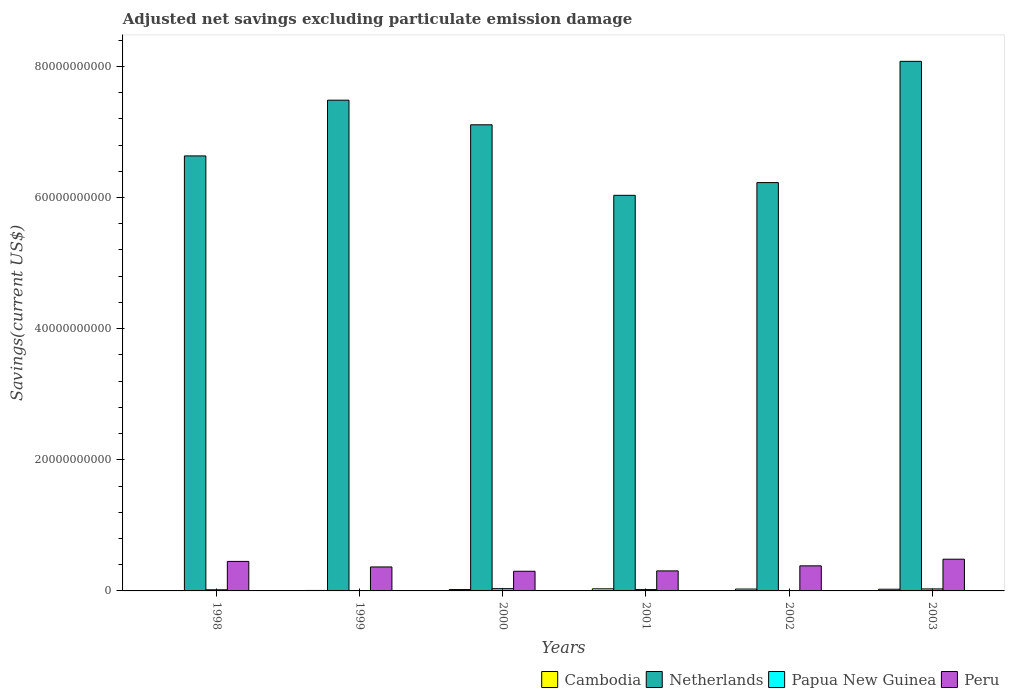How many groups of bars are there?
Offer a terse response. 6. Are the number of bars on each tick of the X-axis equal?
Keep it short and to the point. No. What is the label of the 3rd group of bars from the left?
Keep it short and to the point. 2000. In how many cases, is the number of bars for a given year not equal to the number of legend labels?
Your response must be concise. 3. What is the adjusted net savings in Cambodia in 1999?
Your answer should be compact. 7.21e+07. Across all years, what is the maximum adjusted net savings in Papua New Guinea?
Offer a very short reply. 3.44e+08. What is the total adjusted net savings in Cambodia in the graph?
Provide a succinct answer. 1.14e+09. What is the difference between the adjusted net savings in Netherlands in 2002 and that in 2003?
Offer a very short reply. -1.85e+1. What is the difference between the adjusted net savings in Peru in 2000 and the adjusted net savings in Netherlands in 2001?
Keep it short and to the point. -5.73e+1. What is the average adjusted net savings in Papua New Guinea per year?
Your answer should be very brief. 1.71e+08. In the year 1999, what is the difference between the adjusted net savings in Netherlands and adjusted net savings in Peru?
Make the answer very short. 7.12e+1. What is the ratio of the adjusted net savings in Peru in 2001 to that in 2003?
Your answer should be very brief. 0.63. What is the difference between the highest and the second highest adjusted net savings in Peru?
Offer a terse response. 3.38e+08. What is the difference between the highest and the lowest adjusted net savings in Netherlands?
Give a very brief answer. 2.04e+1. In how many years, is the adjusted net savings in Peru greater than the average adjusted net savings in Peru taken over all years?
Offer a very short reply. 3. Is the sum of the adjusted net savings in Papua New Guinea in 1998 and 2003 greater than the maximum adjusted net savings in Peru across all years?
Your response must be concise. No. How many bars are there?
Offer a very short reply. 21. What is the difference between two consecutive major ticks on the Y-axis?
Keep it short and to the point. 2.00e+1. Does the graph contain any zero values?
Your answer should be very brief. Yes. Does the graph contain grids?
Ensure brevity in your answer.  No. Where does the legend appear in the graph?
Provide a short and direct response. Bottom right. What is the title of the graph?
Ensure brevity in your answer.  Adjusted net savings excluding particulate emission damage. Does "Cabo Verde" appear as one of the legend labels in the graph?
Give a very brief answer. No. What is the label or title of the Y-axis?
Make the answer very short. Savings(current US$). What is the Savings(current US$) of Cambodia in 1998?
Provide a short and direct response. 0. What is the Savings(current US$) in Netherlands in 1998?
Provide a succinct answer. 6.63e+1. What is the Savings(current US$) of Papua New Guinea in 1998?
Provide a succinct answer. 1.72e+08. What is the Savings(current US$) in Peru in 1998?
Provide a short and direct response. 4.50e+09. What is the Savings(current US$) of Cambodia in 1999?
Provide a short and direct response. 7.21e+07. What is the Savings(current US$) of Netherlands in 1999?
Your response must be concise. 7.48e+1. What is the Savings(current US$) in Papua New Guinea in 1999?
Your answer should be very brief. 0. What is the Savings(current US$) of Peru in 1999?
Keep it short and to the point. 3.66e+09. What is the Savings(current US$) in Cambodia in 2000?
Your response must be concise. 2.06e+08. What is the Savings(current US$) of Netherlands in 2000?
Provide a succinct answer. 7.11e+1. What is the Savings(current US$) in Papua New Guinea in 2000?
Your answer should be very brief. 3.44e+08. What is the Savings(current US$) in Peru in 2000?
Your response must be concise. 3.00e+09. What is the Savings(current US$) of Cambodia in 2001?
Provide a short and direct response. 3.20e+08. What is the Savings(current US$) in Netherlands in 2001?
Offer a very short reply. 6.03e+1. What is the Savings(current US$) in Papua New Guinea in 2001?
Ensure brevity in your answer.  2.01e+08. What is the Savings(current US$) in Peru in 2001?
Offer a very short reply. 3.05e+09. What is the Savings(current US$) of Cambodia in 2002?
Provide a succinct answer. 2.86e+08. What is the Savings(current US$) in Netherlands in 2002?
Keep it short and to the point. 6.23e+1. What is the Savings(current US$) in Papua New Guinea in 2002?
Give a very brief answer. 0. What is the Savings(current US$) of Peru in 2002?
Keep it short and to the point. 3.82e+09. What is the Savings(current US$) of Cambodia in 2003?
Give a very brief answer. 2.59e+08. What is the Savings(current US$) in Netherlands in 2003?
Provide a short and direct response. 8.08e+1. What is the Savings(current US$) in Papua New Guinea in 2003?
Your answer should be compact. 3.07e+08. What is the Savings(current US$) of Peru in 2003?
Your answer should be very brief. 4.84e+09. Across all years, what is the maximum Savings(current US$) of Cambodia?
Your answer should be very brief. 3.20e+08. Across all years, what is the maximum Savings(current US$) in Netherlands?
Give a very brief answer. 8.08e+1. Across all years, what is the maximum Savings(current US$) of Papua New Guinea?
Your response must be concise. 3.44e+08. Across all years, what is the maximum Savings(current US$) of Peru?
Make the answer very short. 4.84e+09. Across all years, what is the minimum Savings(current US$) in Netherlands?
Your response must be concise. 6.03e+1. Across all years, what is the minimum Savings(current US$) in Papua New Guinea?
Your response must be concise. 0. Across all years, what is the minimum Savings(current US$) in Peru?
Offer a very short reply. 3.00e+09. What is the total Savings(current US$) of Cambodia in the graph?
Provide a succinct answer. 1.14e+09. What is the total Savings(current US$) of Netherlands in the graph?
Ensure brevity in your answer.  4.16e+11. What is the total Savings(current US$) in Papua New Guinea in the graph?
Keep it short and to the point. 1.02e+09. What is the total Savings(current US$) of Peru in the graph?
Your response must be concise. 2.29e+1. What is the difference between the Savings(current US$) of Netherlands in 1998 and that in 1999?
Ensure brevity in your answer.  -8.50e+09. What is the difference between the Savings(current US$) of Peru in 1998 and that in 1999?
Your answer should be compact. 8.45e+08. What is the difference between the Savings(current US$) of Netherlands in 1998 and that in 2000?
Provide a succinct answer. -4.75e+09. What is the difference between the Savings(current US$) in Papua New Guinea in 1998 and that in 2000?
Offer a very short reply. -1.72e+08. What is the difference between the Savings(current US$) in Peru in 1998 and that in 2000?
Your answer should be compact. 1.50e+09. What is the difference between the Savings(current US$) of Netherlands in 1998 and that in 2001?
Keep it short and to the point. 6.01e+09. What is the difference between the Savings(current US$) in Papua New Guinea in 1998 and that in 2001?
Give a very brief answer. -2.91e+07. What is the difference between the Savings(current US$) in Peru in 1998 and that in 2001?
Your answer should be compact. 1.45e+09. What is the difference between the Savings(current US$) in Netherlands in 1998 and that in 2002?
Ensure brevity in your answer.  4.07e+09. What is the difference between the Savings(current US$) in Peru in 1998 and that in 2002?
Keep it short and to the point. 6.79e+08. What is the difference between the Savings(current US$) in Netherlands in 1998 and that in 2003?
Your answer should be very brief. -1.44e+1. What is the difference between the Savings(current US$) of Papua New Guinea in 1998 and that in 2003?
Offer a very short reply. -1.35e+08. What is the difference between the Savings(current US$) in Peru in 1998 and that in 2003?
Offer a very short reply. -3.38e+08. What is the difference between the Savings(current US$) in Cambodia in 1999 and that in 2000?
Offer a terse response. -1.34e+08. What is the difference between the Savings(current US$) in Netherlands in 1999 and that in 2000?
Keep it short and to the point. 3.75e+09. What is the difference between the Savings(current US$) in Peru in 1999 and that in 2000?
Offer a terse response. 6.57e+08. What is the difference between the Savings(current US$) of Cambodia in 1999 and that in 2001?
Make the answer very short. -2.48e+08. What is the difference between the Savings(current US$) of Netherlands in 1999 and that in 2001?
Your answer should be very brief. 1.45e+1. What is the difference between the Savings(current US$) in Peru in 1999 and that in 2001?
Keep it short and to the point. 6.03e+08. What is the difference between the Savings(current US$) of Cambodia in 1999 and that in 2002?
Your response must be concise. -2.14e+08. What is the difference between the Savings(current US$) in Netherlands in 1999 and that in 2002?
Your answer should be very brief. 1.26e+1. What is the difference between the Savings(current US$) of Peru in 1999 and that in 2002?
Offer a very short reply. -1.66e+08. What is the difference between the Savings(current US$) in Cambodia in 1999 and that in 2003?
Keep it short and to the point. -1.87e+08. What is the difference between the Savings(current US$) of Netherlands in 1999 and that in 2003?
Offer a very short reply. -5.92e+09. What is the difference between the Savings(current US$) of Peru in 1999 and that in 2003?
Give a very brief answer. -1.18e+09. What is the difference between the Savings(current US$) of Cambodia in 2000 and that in 2001?
Your response must be concise. -1.14e+08. What is the difference between the Savings(current US$) of Netherlands in 2000 and that in 2001?
Your answer should be compact. 1.08e+1. What is the difference between the Savings(current US$) of Papua New Guinea in 2000 and that in 2001?
Offer a very short reply. 1.43e+08. What is the difference between the Savings(current US$) in Peru in 2000 and that in 2001?
Provide a succinct answer. -5.41e+07. What is the difference between the Savings(current US$) in Cambodia in 2000 and that in 2002?
Ensure brevity in your answer.  -7.97e+07. What is the difference between the Savings(current US$) of Netherlands in 2000 and that in 2002?
Offer a terse response. 8.82e+09. What is the difference between the Savings(current US$) of Peru in 2000 and that in 2002?
Your answer should be very brief. -8.23e+08. What is the difference between the Savings(current US$) in Cambodia in 2000 and that in 2003?
Provide a short and direct response. -5.29e+07. What is the difference between the Savings(current US$) of Netherlands in 2000 and that in 2003?
Provide a succinct answer. -9.68e+09. What is the difference between the Savings(current US$) in Papua New Guinea in 2000 and that in 2003?
Your answer should be compact. 3.68e+07. What is the difference between the Savings(current US$) in Peru in 2000 and that in 2003?
Make the answer very short. -1.84e+09. What is the difference between the Savings(current US$) of Cambodia in 2001 and that in 2002?
Ensure brevity in your answer.  3.47e+07. What is the difference between the Savings(current US$) of Netherlands in 2001 and that in 2002?
Keep it short and to the point. -1.94e+09. What is the difference between the Savings(current US$) of Peru in 2001 and that in 2002?
Offer a terse response. -7.69e+08. What is the difference between the Savings(current US$) in Cambodia in 2001 and that in 2003?
Your response must be concise. 6.15e+07. What is the difference between the Savings(current US$) in Netherlands in 2001 and that in 2003?
Make the answer very short. -2.04e+1. What is the difference between the Savings(current US$) of Papua New Guinea in 2001 and that in 2003?
Provide a short and direct response. -1.06e+08. What is the difference between the Savings(current US$) of Peru in 2001 and that in 2003?
Offer a terse response. -1.78e+09. What is the difference between the Savings(current US$) in Cambodia in 2002 and that in 2003?
Make the answer very short. 2.68e+07. What is the difference between the Savings(current US$) in Netherlands in 2002 and that in 2003?
Your answer should be compact. -1.85e+1. What is the difference between the Savings(current US$) of Peru in 2002 and that in 2003?
Ensure brevity in your answer.  -1.02e+09. What is the difference between the Savings(current US$) in Netherlands in 1998 and the Savings(current US$) in Peru in 1999?
Give a very brief answer. 6.27e+1. What is the difference between the Savings(current US$) in Papua New Guinea in 1998 and the Savings(current US$) in Peru in 1999?
Offer a very short reply. -3.48e+09. What is the difference between the Savings(current US$) of Netherlands in 1998 and the Savings(current US$) of Papua New Guinea in 2000?
Your response must be concise. 6.60e+1. What is the difference between the Savings(current US$) in Netherlands in 1998 and the Savings(current US$) in Peru in 2000?
Provide a short and direct response. 6.33e+1. What is the difference between the Savings(current US$) of Papua New Guinea in 1998 and the Savings(current US$) of Peru in 2000?
Make the answer very short. -2.83e+09. What is the difference between the Savings(current US$) in Netherlands in 1998 and the Savings(current US$) in Papua New Guinea in 2001?
Offer a terse response. 6.61e+1. What is the difference between the Savings(current US$) of Netherlands in 1998 and the Savings(current US$) of Peru in 2001?
Keep it short and to the point. 6.33e+1. What is the difference between the Savings(current US$) in Papua New Guinea in 1998 and the Savings(current US$) in Peru in 2001?
Your response must be concise. -2.88e+09. What is the difference between the Savings(current US$) of Netherlands in 1998 and the Savings(current US$) of Peru in 2002?
Your answer should be very brief. 6.25e+1. What is the difference between the Savings(current US$) of Papua New Guinea in 1998 and the Savings(current US$) of Peru in 2002?
Make the answer very short. -3.65e+09. What is the difference between the Savings(current US$) of Netherlands in 1998 and the Savings(current US$) of Papua New Guinea in 2003?
Keep it short and to the point. 6.60e+1. What is the difference between the Savings(current US$) of Netherlands in 1998 and the Savings(current US$) of Peru in 2003?
Ensure brevity in your answer.  6.15e+1. What is the difference between the Savings(current US$) in Papua New Guinea in 1998 and the Savings(current US$) in Peru in 2003?
Offer a terse response. -4.67e+09. What is the difference between the Savings(current US$) of Cambodia in 1999 and the Savings(current US$) of Netherlands in 2000?
Keep it short and to the point. -7.10e+1. What is the difference between the Savings(current US$) of Cambodia in 1999 and the Savings(current US$) of Papua New Guinea in 2000?
Keep it short and to the point. -2.72e+08. What is the difference between the Savings(current US$) of Cambodia in 1999 and the Savings(current US$) of Peru in 2000?
Provide a succinct answer. -2.93e+09. What is the difference between the Savings(current US$) of Netherlands in 1999 and the Savings(current US$) of Papua New Guinea in 2000?
Your answer should be very brief. 7.45e+1. What is the difference between the Savings(current US$) in Netherlands in 1999 and the Savings(current US$) in Peru in 2000?
Keep it short and to the point. 7.18e+1. What is the difference between the Savings(current US$) of Cambodia in 1999 and the Savings(current US$) of Netherlands in 2001?
Provide a short and direct response. -6.03e+1. What is the difference between the Savings(current US$) of Cambodia in 1999 and the Savings(current US$) of Papua New Guinea in 2001?
Your response must be concise. -1.29e+08. What is the difference between the Savings(current US$) of Cambodia in 1999 and the Savings(current US$) of Peru in 2001?
Ensure brevity in your answer.  -2.98e+09. What is the difference between the Savings(current US$) of Netherlands in 1999 and the Savings(current US$) of Papua New Guinea in 2001?
Offer a very short reply. 7.46e+1. What is the difference between the Savings(current US$) in Netherlands in 1999 and the Savings(current US$) in Peru in 2001?
Offer a terse response. 7.18e+1. What is the difference between the Savings(current US$) of Cambodia in 1999 and the Savings(current US$) of Netherlands in 2002?
Give a very brief answer. -6.22e+1. What is the difference between the Savings(current US$) in Cambodia in 1999 and the Savings(current US$) in Peru in 2002?
Give a very brief answer. -3.75e+09. What is the difference between the Savings(current US$) of Netherlands in 1999 and the Savings(current US$) of Peru in 2002?
Give a very brief answer. 7.10e+1. What is the difference between the Savings(current US$) of Cambodia in 1999 and the Savings(current US$) of Netherlands in 2003?
Keep it short and to the point. -8.07e+1. What is the difference between the Savings(current US$) in Cambodia in 1999 and the Savings(current US$) in Papua New Guinea in 2003?
Provide a short and direct response. -2.35e+08. What is the difference between the Savings(current US$) in Cambodia in 1999 and the Savings(current US$) in Peru in 2003?
Provide a succinct answer. -4.77e+09. What is the difference between the Savings(current US$) of Netherlands in 1999 and the Savings(current US$) of Papua New Guinea in 2003?
Your answer should be very brief. 7.45e+1. What is the difference between the Savings(current US$) in Netherlands in 1999 and the Savings(current US$) in Peru in 2003?
Keep it short and to the point. 7.00e+1. What is the difference between the Savings(current US$) in Cambodia in 2000 and the Savings(current US$) in Netherlands in 2001?
Provide a succinct answer. -6.01e+1. What is the difference between the Savings(current US$) of Cambodia in 2000 and the Savings(current US$) of Papua New Guinea in 2001?
Your answer should be very brief. 4.63e+06. What is the difference between the Savings(current US$) in Cambodia in 2000 and the Savings(current US$) in Peru in 2001?
Offer a very short reply. -2.85e+09. What is the difference between the Savings(current US$) in Netherlands in 2000 and the Savings(current US$) in Papua New Guinea in 2001?
Ensure brevity in your answer.  7.09e+1. What is the difference between the Savings(current US$) in Netherlands in 2000 and the Savings(current US$) in Peru in 2001?
Your answer should be very brief. 6.80e+1. What is the difference between the Savings(current US$) in Papua New Guinea in 2000 and the Savings(current US$) in Peru in 2001?
Offer a very short reply. -2.71e+09. What is the difference between the Savings(current US$) in Cambodia in 2000 and the Savings(current US$) in Netherlands in 2002?
Ensure brevity in your answer.  -6.21e+1. What is the difference between the Savings(current US$) of Cambodia in 2000 and the Savings(current US$) of Peru in 2002?
Keep it short and to the point. -3.62e+09. What is the difference between the Savings(current US$) in Netherlands in 2000 and the Savings(current US$) in Peru in 2002?
Offer a very short reply. 6.73e+1. What is the difference between the Savings(current US$) of Papua New Guinea in 2000 and the Savings(current US$) of Peru in 2002?
Give a very brief answer. -3.48e+09. What is the difference between the Savings(current US$) of Cambodia in 2000 and the Savings(current US$) of Netherlands in 2003?
Make the answer very short. -8.06e+1. What is the difference between the Savings(current US$) of Cambodia in 2000 and the Savings(current US$) of Papua New Guinea in 2003?
Your answer should be very brief. -1.01e+08. What is the difference between the Savings(current US$) in Cambodia in 2000 and the Savings(current US$) in Peru in 2003?
Your response must be concise. -4.63e+09. What is the difference between the Savings(current US$) of Netherlands in 2000 and the Savings(current US$) of Papua New Guinea in 2003?
Provide a succinct answer. 7.08e+1. What is the difference between the Savings(current US$) of Netherlands in 2000 and the Savings(current US$) of Peru in 2003?
Your answer should be very brief. 6.63e+1. What is the difference between the Savings(current US$) in Papua New Guinea in 2000 and the Savings(current US$) in Peru in 2003?
Your answer should be very brief. -4.49e+09. What is the difference between the Savings(current US$) in Cambodia in 2001 and the Savings(current US$) in Netherlands in 2002?
Your answer should be very brief. -6.20e+1. What is the difference between the Savings(current US$) in Cambodia in 2001 and the Savings(current US$) in Peru in 2002?
Your answer should be very brief. -3.50e+09. What is the difference between the Savings(current US$) in Netherlands in 2001 and the Savings(current US$) in Peru in 2002?
Offer a terse response. 5.65e+1. What is the difference between the Savings(current US$) in Papua New Guinea in 2001 and the Savings(current US$) in Peru in 2002?
Your response must be concise. -3.62e+09. What is the difference between the Savings(current US$) of Cambodia in 2001 and the Savings(current US$) of Netherlands in 2003?
Offer a terse response. -8.04e+1. What is the difference between the Savings(current US$) of Cambodia in 2001 and the Savings(current US$) of Papua New Guinea in 2003?
Offer a terse response. 1.32e+07. What is the difference between the Savings(current US$) in Cambodia in 2001 and the Savings(current US$) in Peru in 2003?
Make the answer very short. -4.52e+09. What is the difference between the Savings(current US$) in Netherlands in 2001 and the Savings(current US$) in Papua New Guinea in 2003?
Your answer should be compact. 6.00e+1. What is the difference between the Savings(current US$) in Netherlands in 2001 and the Savings(current US$) in Peru in 2003?
Give a very brief answer. 5.55e+1. What is the difference between the Savings(current US$) in Papua New Guinea in 2001 and the Savings(current US$) in Peru in 2003?
Your response must be concise. -4.64e+09. What is the difference between the Savings(current US$) of Cambodia in 2002 and the Savings(current US$) of Netherlands in 2003?
Offer a terse response. -8.05e+1. What is the difference between the Savings(current US$) in Cambodia in 2002 and the Savings(current US$) in Papua New Guinea in 2003?
Ensure brevity in your answer.  -2.15e+07. What is the difference between the Savings(current US$) in Cambodia in 2002 and the Savings(current US$) in Peru in 2003?
Your response must be concise. -4.55e+09. What is the difference between the Savings(current US$) in Netherlands in 2002 and the Savings(current US$) in Papua New Guinea in 2003?
Offer a terse response. 6.20e+1. What is the difference between the Savings(current US$) of Netherlands in 2002 and the Savings(current US$) of Peru in 2003?
Provide a succinct answer. 5.74e+1. What is the average Savings(current US$) in Cambodia per year?
Your answer should be very brief. 1.90e+08. What is the average Savings(current US$) of Netherlands per year?
Keep it short and to the point. 6.93e+1. What is the average Savings(current US$) of Papua New Guinea per year?
Provide a short and direct response. 1.71e+08. What is the average Savings(current US$) of Peru per year?
Your answer should be very brief. 3.81e+09. In the year 1998, what is the difference between the Savings(current US$) in Netherlands and Savings(current US$) in Papua New Guinea?
Your answer should be compact. 6.62e+1. In the year 1998, what is the difference between the Savings(current US$) of Netherlands and Savings(current US$) of Peru?
Your response must be concise. 6.18e+1. In the year 1998, what is the difference between the Savings(current US$) in Papua New Guinea and Savings(current US$) in Peru?
Make the answer very short. -4.33e+09. In the year 1999, what is the difference between the Savings(current US$) of Cambodia and Savings(current US$) of Netherlands?
Your answer should be compact. -7.48e+1. In the year 1999, what is the difference between the Savings(current US$) in Cambodia and Savings(current US$) in Peru?
Offer a very short reply. -3.58e+09. In the year 1999, what is the difference between the Savings(current US$) in Netherlands and Savings(current US$) in Peru?
Offer a terse response. 7.12e+1. In the year 2000, what is the difference between the Savings(current US$) in Cambodia and Savings(current US$) in Netherlands?
Ensure brevity in your answer.  -7.09e+1. In the year 2000, what is the difference between the Savings(current US$) of Cambodia and Savings(current US$) of Papua New Guinea?
Make the answer very short. -1.38e+08. In the year 2000, what is the difference between the Savings(current US$) of Cambodia and Savings(current US$) of Peru?
Offer a very short reply. -2.79e+09. In the year 2000, what is the difference between the Savings(current US$) of Netherlands and Savings(current US$) of Papua New Guinea?
Offer a very short reply. 7.07e+1. In the year 2000, what is the difference between the Savings(current US$) in Netherlands and Savings(current US$) in Peru?
Your answer should be very brief. 6.81e+1. In the year 2000, what is the difference between the Savings(current US$) in Papua New Guinea and Savings(current US$) in Peru?
Offer a very short reply. -2.66e+09. In the year 2001, what is the difference between the Savings(current US$) in Cambodia and Savings(current US$) in Netherlands?
Provide a short and direct response. -6.00e+1. In the year 2001, what is the difference between the Savings(current US$) in Cambodia and Savings(current US$) in Papua New Guinea?
Provide a short and direct response. 1.19e+08. In the year 2001, what is the difference between the Savings(current US$) in Cambodia and Savings(current US$) in Peru?
Provide a short and direct response. -2.73e+09. In the year 2001, what is the difference between the Savings(current US$) of Netherlands and Savings(current US$) of Papua New Guinea?
Provide a succinct answer. 6.01e+1. In the year 2001, what is the difference between the Savings(current US$) of Netherlands and Savings(current US$) of Peru?
Provide a succinct answer. 5.73e+1. In the year 2001, what is the difference between the Savings(current US$) of Papua New Guinea and Savings(current US$) of Peru?
Make the answer very short. -2.85e+09. In the year 2002, what is the difference between the Savings(current US$) in Cambodia and Savings(current US$) in Netherlands?
Make the answer very short. -6.20e+1. In the year 2002, what is the difference between the Savings(current US$) of Cambodia and Savings(current US$) of Peru?
Your answer should be very brief. -3.54e+09. In the year 2002, what is the difference between the Savings(current US$) of Netherlands and Savings(current US$) of Peru?
Provide a succinct answer. 5.85e+1. In the year 2003, what is the difference between the Savings(current US$) in Cambodia and Savings(current US$) in Netherlands?
Provide a short and direct response. -8.05e+1. In the year 2003, what is the difference between the Savings(current US$) of Cambodia and Savings(current US$) of Papua New Guinea?
Your answer should be very brief. -4.83e+07. In the year 2003, what is the difference between the Savings(current US$) in Cambodia and Savings(current US$) in Peru?
Keep it short and to the point. -4.58e+09. In the year 2003, what is the difference between the Savings(current US$) of Netherlands and Savings(current US$) of Papua New Guinea?
Offer a very short reply. 8.05e+1. In the year 2003, what is the difference between the Savings(current US$) of Netherlands and Savings(current US$) of Peru?
Make the answer very short. 7.59e+1. In the year 2003, what is the difference between the Savings(current US$) of Papua New Guinea and Savings(current US$) of Peru?
Your answer should be compact. -4.53e+09. What is the ratio of the Savings(current US$) of Netherlands in 1998 to that in 1999?
Ensure brevity in your answer.  0.89. What is the ratio of the Savings(current US$) of Peru in 1998 to that in 1999?
Provide a short and direct response. 1.23. What is the ratio of the Savings(current US$) in Netherlands in 1998 to that in 2000?
Provide a short and direct response. 0.93. What is the ratio of the Savings(current US$) of Papua New Guinea in 1998 to that in 2000?
Give a very brief answer. 0.5. What is the ratio of the Savings(current US$) of Peru in 1998 to that in 2000?
Offer a very short reply. 1.5. What is the ratio of the Savings(current US$) in Netherlands in 1998 to that in 2001?
Your answer should be compact. 1.1. What is the ratio of the Savings(current US$) of Papua New Guinea in 1998 to that in 2001?
Provide a succinct answer. 0.86. What is the ratio of the Savings(current US$) in Peru in 1998 to that in 2001?
Provide a succinct answer. 1.47. What is the ratio of the Savings(current US$) in Netherlands in 1998 to that in 2002?
Your response must be concise. 1.07. What is the ratio of the Savings(current US$) of Peru in 1998 to that in 2002?
Provide a succinct answer. 1.18. What is the ratio of the Savings(current US$) in Netherlands in 1998 to that in 2003?
Offer a very short reply. 0.82. What is the ratio of the Savings(current US$) of Papua New Guinea in 1998 to that in 2003?
Ensure brevity in your answer.  0.56. What is the ratio of the Savings(current US$) in Peru in 1998 to that in 2003?
Ensure brevity in your answer.  0.93. What is the ratio of the Savings(current US$) of Netherlands in 1999 to that in 2000?
Offer a very short reply. 1.05. What is the ratio of the Savings(current US$) of Peru in 1999 to that in 2000?
Your answer should be very brief. 1.22. What is the ratio of the Savings(current US$) of Cambodia in 1999 to that in 2001?
Offer a terse response. 0.23. What is the ratio of the Savings(current US$) in Netherlands in 1999 to that in 2001?
Your response must be concise. 1.24. What is the ratio of the Savings(current US$) in Peru in 1999 to that in 2001?
Ensure brevity in your answer.  1.2. What is the ratio of the Savings(current US$) in Cambodia in 1999 to that in 2002?
Your response must be concise. 0.25. What is the ratio of the Savings(current US$) in Netherlands in 1999 to that in 2002?
Your answer should be compact. 1.2. What is the ratio of the Savings(current US$) in Peru in 1999 to that in 2002?
Ensure brevity in your answer.  0.96. What is the ratio of the Savings(current US$) of Cambodia in 1999 to that in 2003?
Ensure brevity in your answer.  0.28. What is the ratio of the Savings(current US$) of Netherlands in 1999 to that in 2003?
Offer a terse response. 0.93. What is the ratio of the Savings(current US$) of Peru in 1999 to that in 2003?
Make the answer very short. 0.76. What is the ratio of the Savings(current US$) of Cambodia in 2000 to that in 2001?
Your answer should be very brief. 0.64. What is the ratio of the Savings(current US$) in Netherlands in 2000 to that in 2001?
Provide a short and direct response. 1.18. What is the ratio of the Savings(current US$) in Papua New Guinea in 2000 to that in 2001?
Your answer should be compact. 1.71. What is the ratio of the Savings(current US$) of Peru in 2000 to that in 2001?
Ensure brevity in your answer.  0.98. What is the ratio of the Savings(current US$) in Cambodia in 2000 to that in 2002?
Offer a terse response. 0.72. What is the ratio of the Savings(current US$) of Netherlands in 2000 to that in 2002?
Offer a very short reply. 1.14. What is the ratio of the Savings(current US$) in Peru in 2000 to that in 2002?
Offer a very short reply. 0.78. What is the ratio of the Savings(current US$) in Cambodia in 2000 to that in 2003?
Make the answer very short. 0.8. What is the ratio of the Savings(current US$) of Netherlands in 2000 to that in 2003?
Offer a terse response. 0.88. What is the ratio of the Savings(current US$) in Papua New Guinea in 2000 to that in 2003?
Make the answer very short. 1.12. What is the ratio of the Savings(current US$) of Peru in 2000 to that in 2003?
Your answer should be very brief. 0.62. What is the ratio of the Savings(current US$) in Cambodia in 2001 to that in 2002?
Your answer should be very brief. 1.12. What is the ratio of the Savings(current US$) of Netherlands in 2001 to that in 2002?
Offer a very short reply. 0.97. What is the ratio of the Savings(current US$) of Peru in 2001 to that in 2002?
Give a very brief answer. 0.8. What is the ratio of the Savings(current US$) of Cambodia in 2001 to that in 2003?
Provide a short and direct response. 1.24. What is the ratio of the Savings(current US$) in Netherlands in 2001 to that in 2003?
Your answer should be very brief. 0.75. What is the ratio of the Savings(current US$) of Papua New Guinea in 2001 to that in 2003?
Give a very brief answer. 0.66. What is the ratio of the Savings(current US$) in Peru in 2001 to that in 2003?
Provide a succinct answer. 0.63. What is the ratio of the Savings(current US$) in Cambodia in 2002 to that in 2003?
Ensure brevity in your answer.  1.1. What is the ratio of the Savings(current US$) in Netherlands in 2002 to that in 2003?
Your answer should be very brief. 0.77. What is the ratio of the Savings(current US$) of Peru in 2002 to that in 2003?
Your answer should be compact. 0.79. What is the difference between the highest and the second highest Savings(current US$) of Cambodia?
Keep it short and to the point. 3.47e+07. What is the difference between the highest and the second highest Savings(current US$) of Netherlands?
Ensure brevity in your answer.  5.92e+09. What is the difference between the highest and the second highest Savings(current US$) of Papua New Guinea?
Make the answer very short. 3.68e+07. What is the difference between the highest and the second highest Savings(current US$) in Peru?
Your answer should be compact. 3.38e+08. What is the difference between the highest and the lowest Savings(current US$) in Cambodia?
Provide a short and direct response. 3.20e+08. What is the difference between the highest and the lowest Savings(current US$) in Netherlands?
Offer a very short reply. 2.04e+1. What is the difference between the highest and the lowest Savings(current US$) in Papua New Guinea?
Offer a terse response. 3.44e+08. What is the difference between the highest and the lowest Savings(current US$) of Peru?
Offer a terse response. 1.84e+09. 